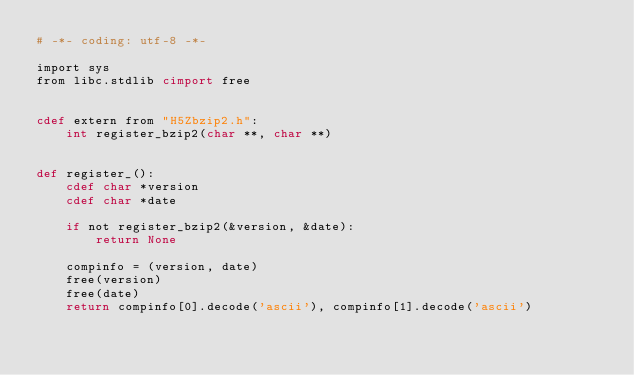<code> <loc_0><loc_0><loc_500><loc_500><_Cython_># -*- coding: utf-8 -*-

import sys
from libc.stdlib cimport free


cdef extern from "H5Zbzip2.h":
    int register_bzip2(char **, char **)


def register_():
    cdef char *version
    cdef char *date

    if not register_bzip2(&version, &date):
        return None

    compinfo = (version, date)
    free(version)
    free(date)
    return compinfo[0].decode('ascii'), compinfo[1].decode('ascii')
</code> 